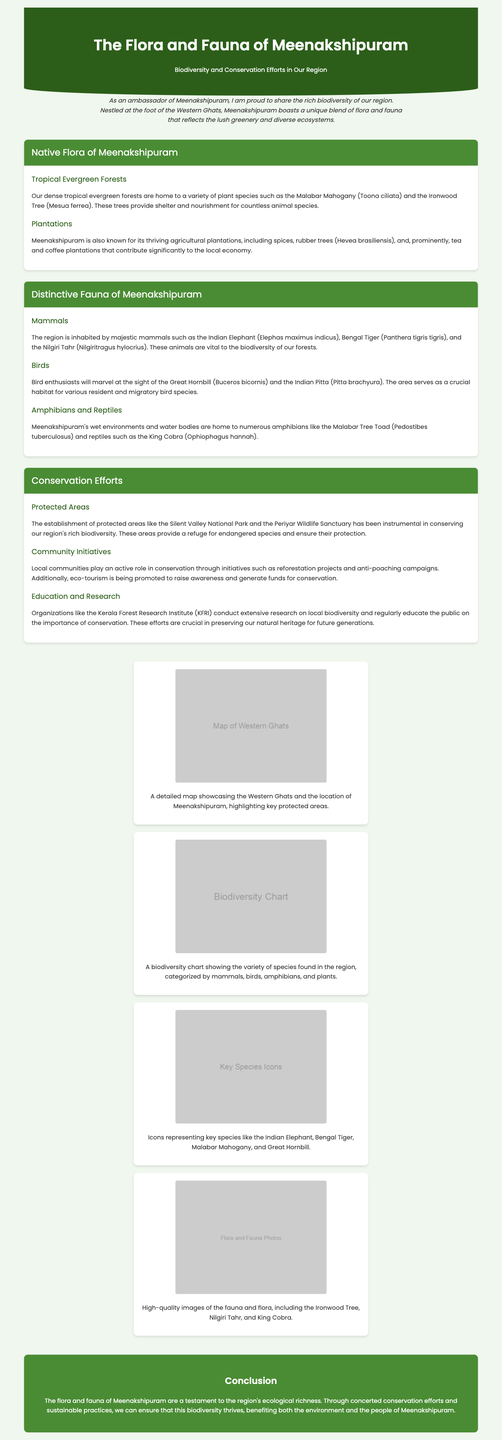What is the title of the infographic? The title of the infographic is prominently displayed at the top, which indicates the main subject of the document.
Answer: The Flora and Fauna of Meenakshipuram What type of forests are mentioned as native to Meenakshipuram? The document specifies that there are particular types of forests in Meenakshipuram, highlighting their ecosystem.
Answer: Tropical Evergreen Forests Which mammal is listed first under the distinctive fauna? The fauna section starts with an introduction of mammals, listing specific examples in a particular order.
Answer: Indian Elephant What initiative do local communities engage in for conservation? The document discusses various actions taken by local communities to help in biodiversity conservation.
Answer: Reforestation projects What park is mentioned as a protected area? The document lists specific protected areas that are crucial for conservation efforts in the region.
Answer: Silent Valley National Park How many types of fauna categories are mentioned? The distinct categories of fauna are outlined in the relevant section, showing the diversity present.
Answer: Three Which species of tree is specifically named in the document? The flora section mentions particular trees that characterize the area and contribute to the ecosystem.
Answer: Malabar Mahogany What organization conducts research on local biodiversity? The document highlights organizations involved in education and research regarding the region's flora and fauna.
Answer: Kerala Forest Research Institute What color scheme dominates the header of the infographic? The design elements of the infographic include specific colors that contribute to its aesthetic appeal.
Answer: Green 